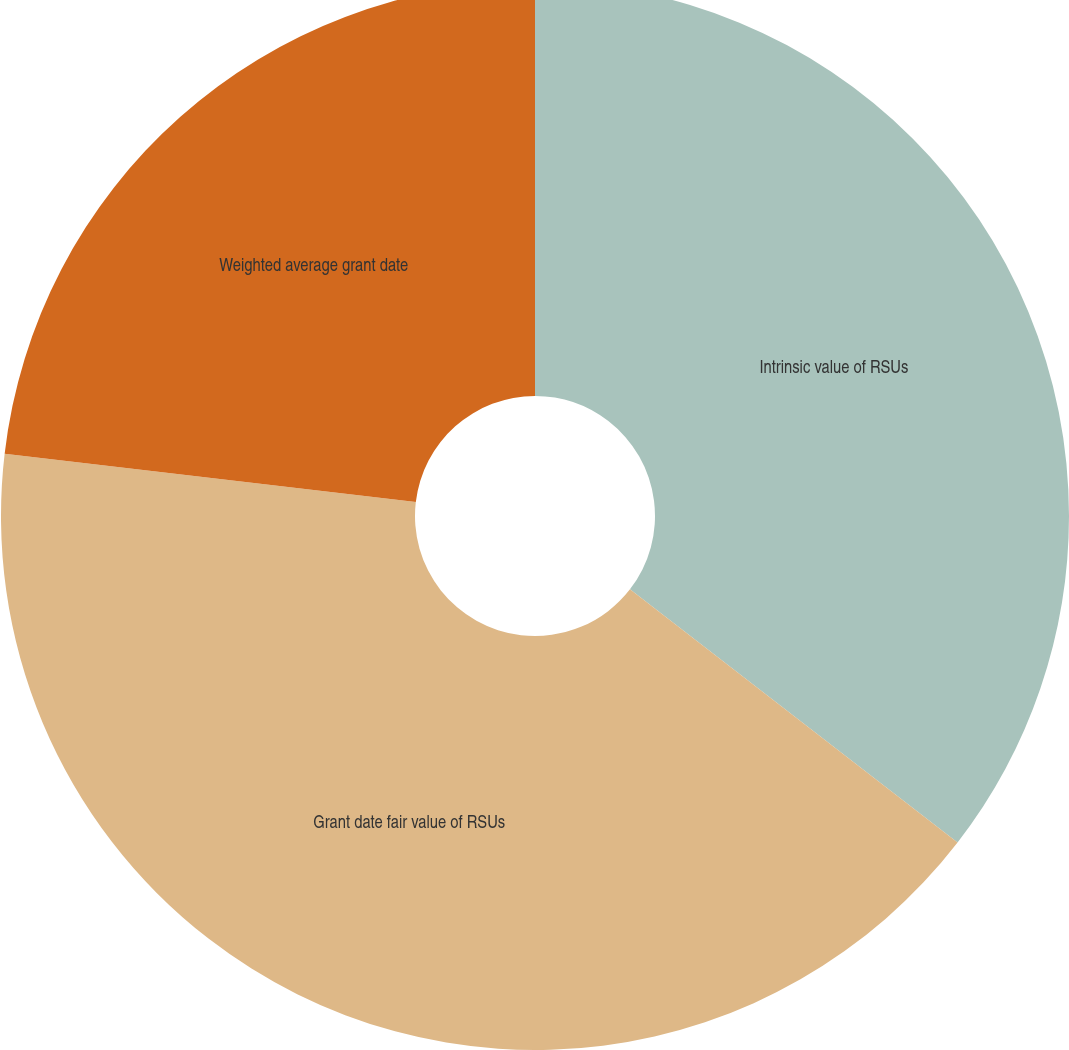<chart> <loc_0><loc_0><loc_500><loc_500><pie_chart><fcel>Intrinsic value of RSUs<fcel>Grant date fair value of RSUs<fcel>Weighted average grant date<nl><fcel>35.47%<fcel>41.39%<fcel>23.14%<nl></chart> 